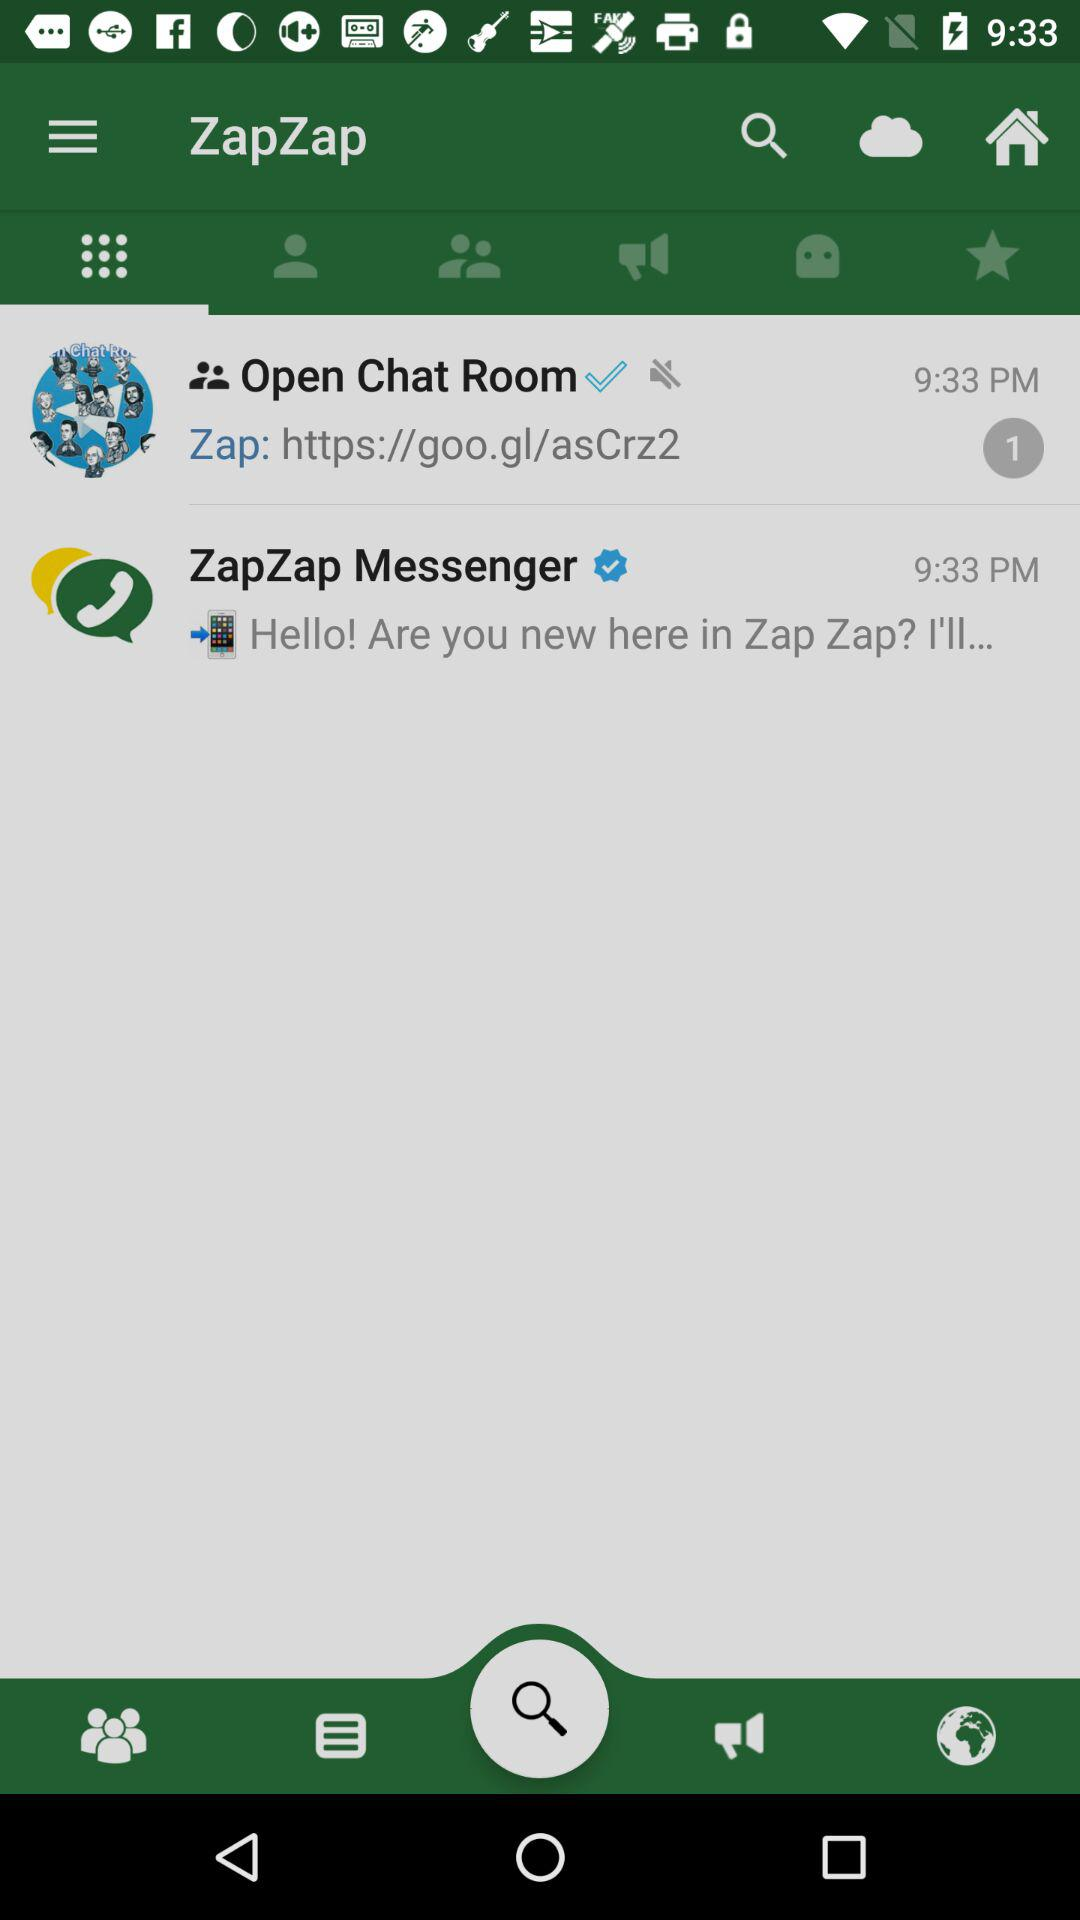What link is shared by Zap in the "Open Chat Room"? The link is https://goo.gl/asCrz2. 